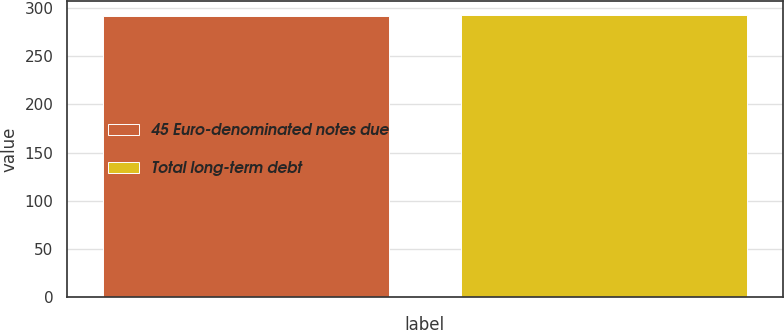Convert chart. <chart><loc_0><loc_0><loc_500><loc_500><bar_chart><fcel>45 Euro-denominated notes due<fcel>Total long-term debt<nl><fcel>291.9<fcel>292<nl></chart> 